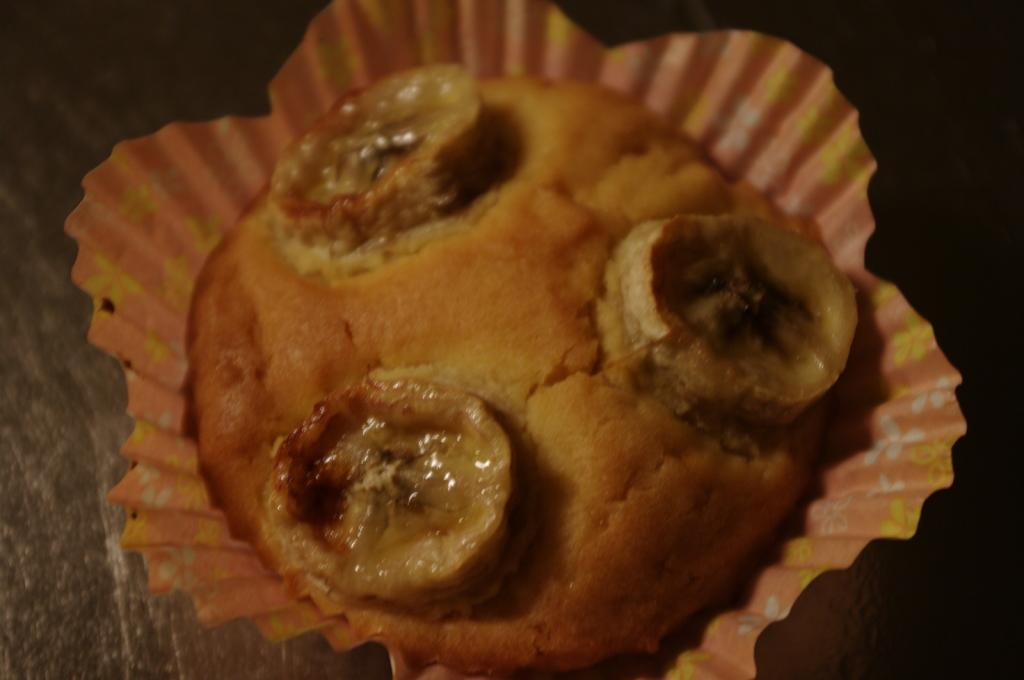What type of dessert is in the image? There is a cupcake in the image. What colors can be seen on the cupcake? The cupcake is brown and cream in color. What is the cupcake placed in? The cupcake is in a cup. What colors are present on the cup? The cup is orange, white, and yellow in color. What is the color of the surface the cupcake is on? The cupcake is on a black surface. What type of secretary can be seen working in the image? There is no secretary present in the image; it features a cupcake in a cup. What type of stone is visible in the image? There is no stone present in the image; it features a cupcake in a cup. 